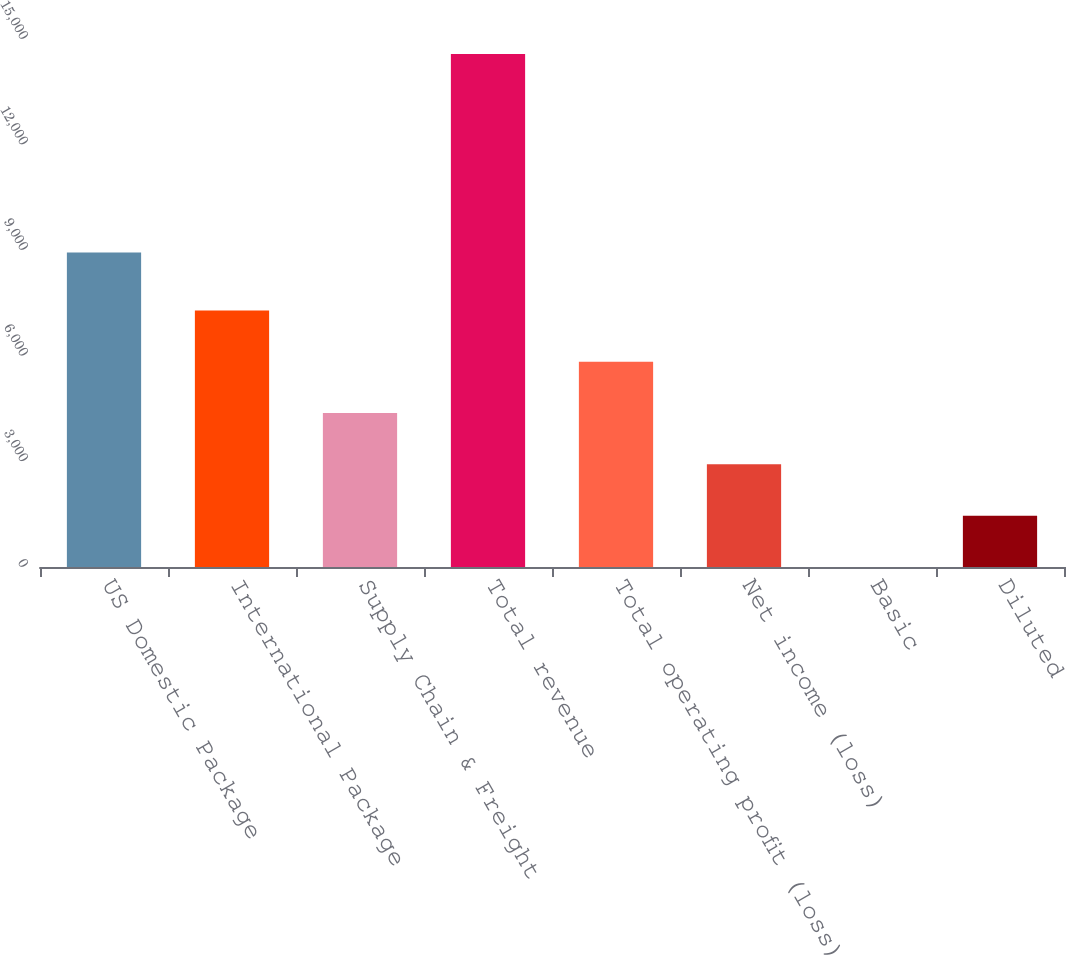Convert chart to OTSL. <chart><loc_0><loc_0><loc_500><loc_500><bar_chart><fcel>US Domestic Package<fcel>International Package<fcel>Supply Chain & Freight<fcel>Total revenue<fcel>Total operating profit (loss)<fcel>Net income (loss)<fcel>Basic<fcel>Diluted<nl><fcel>8933<fcel>7286.43<fcel>4372.59<fcel>14571<fcel>5829.51<fcel>2915.67<fcel>1.83<fcel>1458.75<nl></chart> 